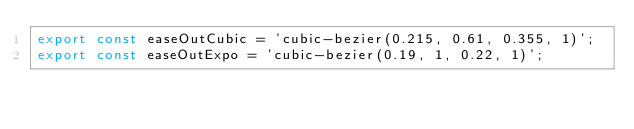Convert code to text. <code><loc_0><loc_0><loc_500><loc_500><_TypeScript_>export const easeOutCubic = 'cubic-bezier(0.215, 0.61, 0.355, 1)';
export const easeOutExpo = 'cubic-bezier(0.19, 1, 0.22, 1)';
</code> 